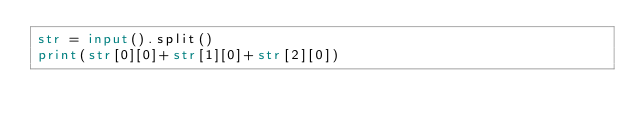<code> <loc_0><loc_0><loc_500><loc_500><_Python_>str = input().split()
print(str[0][0]+str[1][0]+str[2][0])</code> 